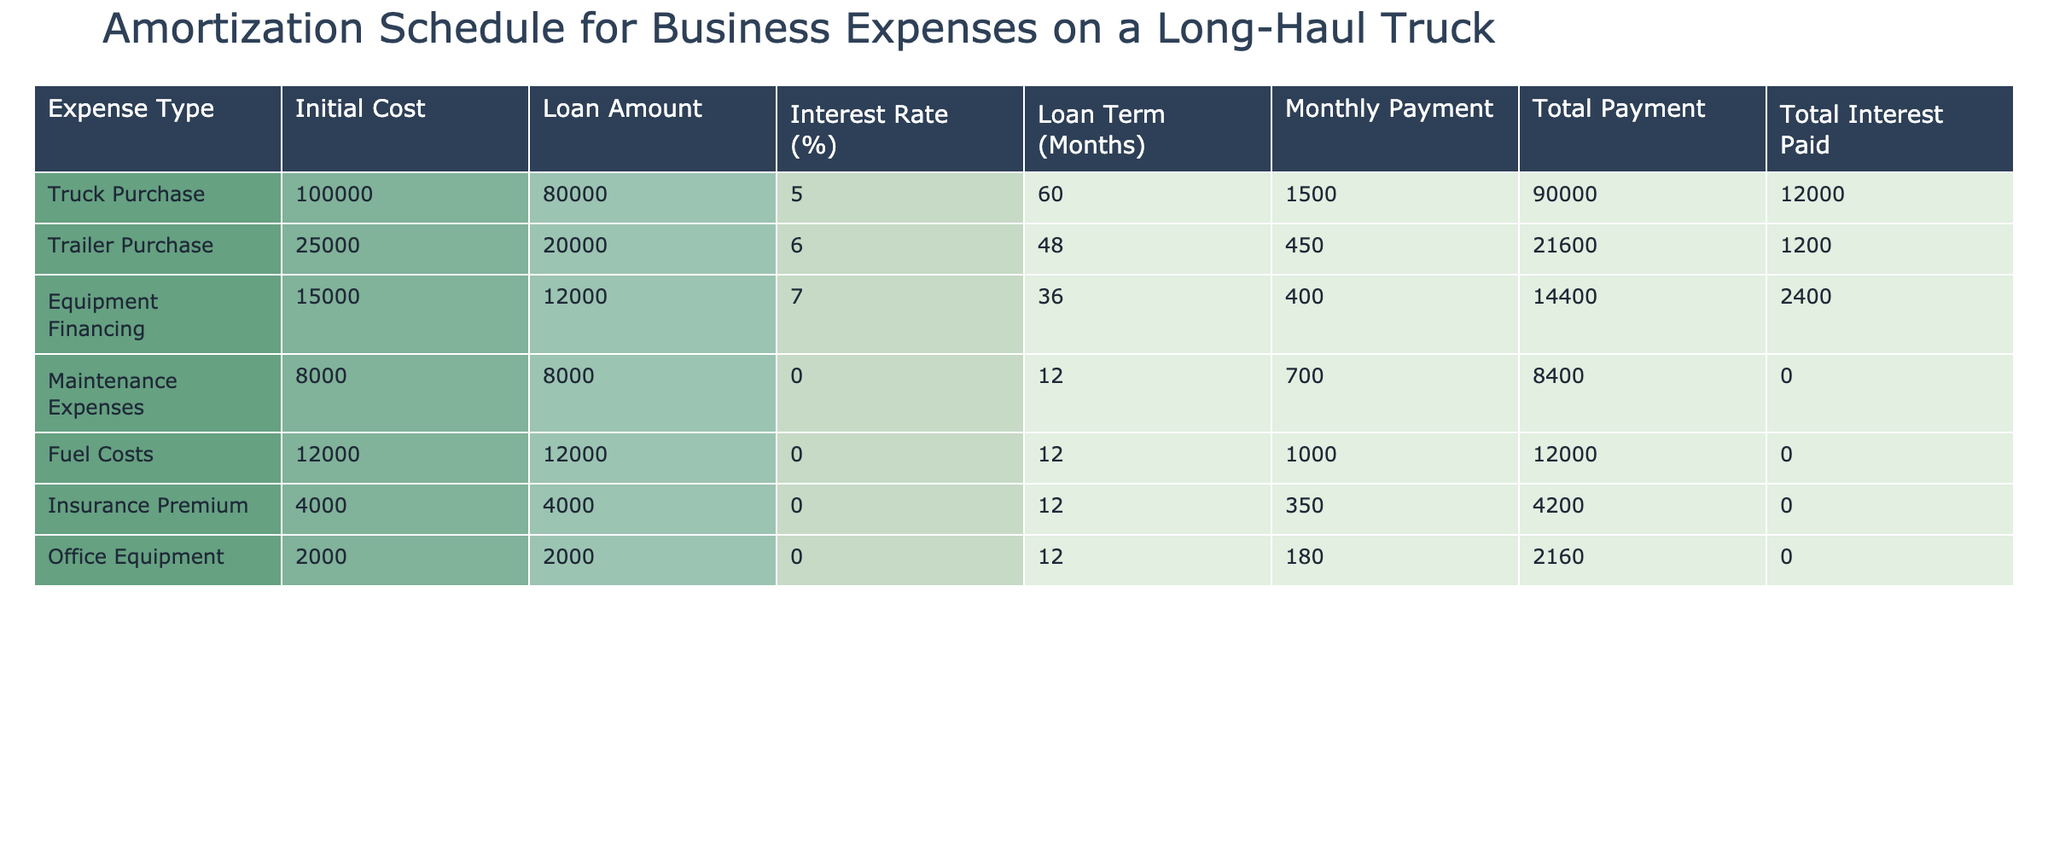What is the monthly payment for the Truck Purchase? The monthly payment for the Truck Purchase can be found in the 'Monthly Payment' column corresponding to 'Truck Purchase'. It is 1500.
Answer: 1500 What is the total interest paid for the Trailer Purchase? The total interest paid for the Trailer Purchase can be found in the 'Total Interest Paid' column corresponding to 'Trailer Purchase'. It is 1200.
Answer: 1200 What is the total payment for Equipment Financing? To find the total payment for Equipment Financing, look at the 'Total Payment' column for 'Equipment Financing'. The value is 14400.
Answer: 14400 Is the Interest Rate for Fuel Costs greater than 0%? The Interest Rate for Fuel Costs is listed as 0%, which means it is not greater than 0%. Therefore, the answer is no.
Answer: No Which expense type has the highest Monthly Payment? The 'Monthly Payment' values need to be compared. Truck Purchase has a monthly payment of 1500, Trailer Purchase has 450, Equipment Financing has 400, Maintenance Expenses has 700, Fuel Costs has 1000, Insurance Premium has 350, and Office Equipment has 180. The Truck Purchase has the highest monthly payment of 1500.
Answer: Truck Purchase What is the sum of all the Monthly Payments for the listed expenses? To calculate the sum, we add all the Monthly Payments: 1500 (Truck Purchase) + 450 (Trailer Purchase) + 400 (Equipment Financing) + 700 (Maintenance Expenses) + 1000 (Fuel Costs) + 350 (Insurance Premium) + 180 (Office Equipment) = 4180.
Answer: 4180 How many expense types have a Loan Amount of less than 10000? We need to filter the 'Loan Amount' column. The Expense Types with Loan Amounts less than 10000 are Maintenance Expenses (8000), Fuel Costs (12000), and Office Equipment (2000). The count of expense types is 2.
Answer: 2 What is the average Total Payment across all expenses? To find the average, we first sum the Total Payments: 90000 (Truck Purchase) + 21600 (Trailer Purchase) + 14400 (Equipment Financing) + 8400 (Maintenance Expenses) + 12000 (Fuel Costs) + 4200 (Insurance Premium) + 2160 (Office Equipment) = 139760. Then divide by the number of expense types, which is 7: 139760/7 ≈ 19965.71.
Answer: 19965.71 Does the Equipment Financing have a higher Monthly Payment than the Insurance Premium? The Monthly Payment for Equipment Financing is 400, while the Monthly Payment for Insurance Premium is 350. Since 400 is greater than 350, the statement is true.
Answer: Yes 